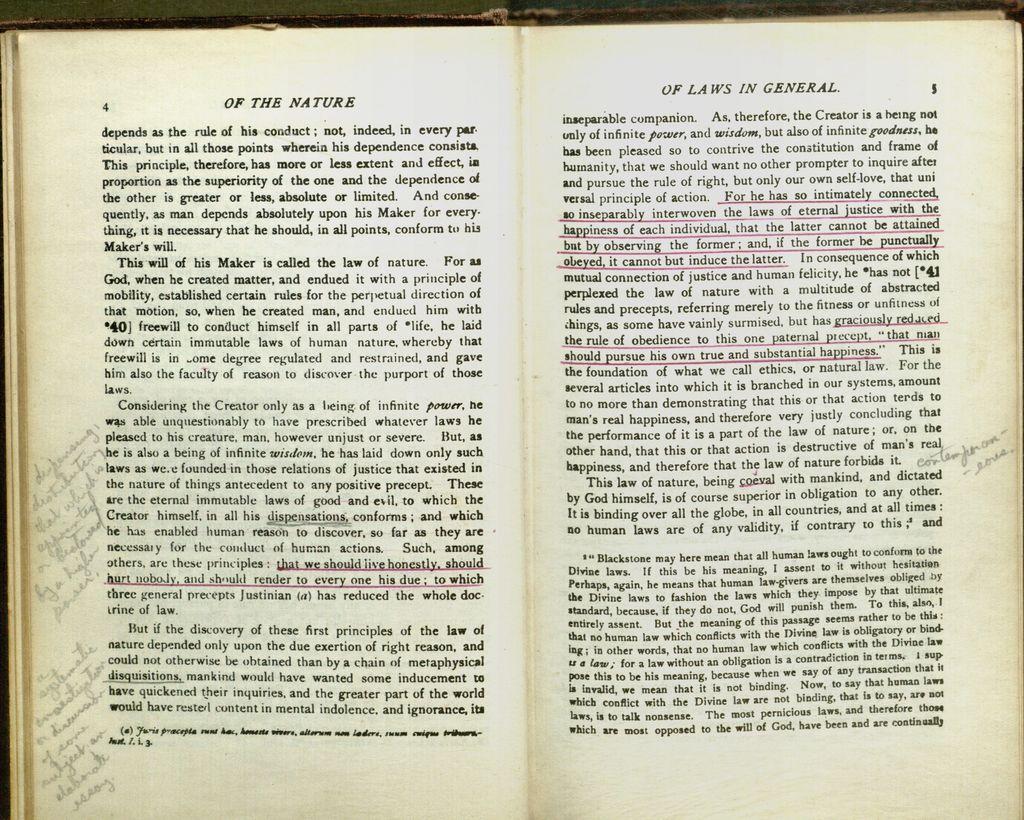What is the title of the page on the left?
Offer a terse response. Of the nature. What page numbers are shown?
Make the answer very short. 4 and 5. 